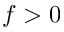Convert formula to latex. <formula><loc_0><loc_0><loc_500><loc_500>f > 0</formula> 